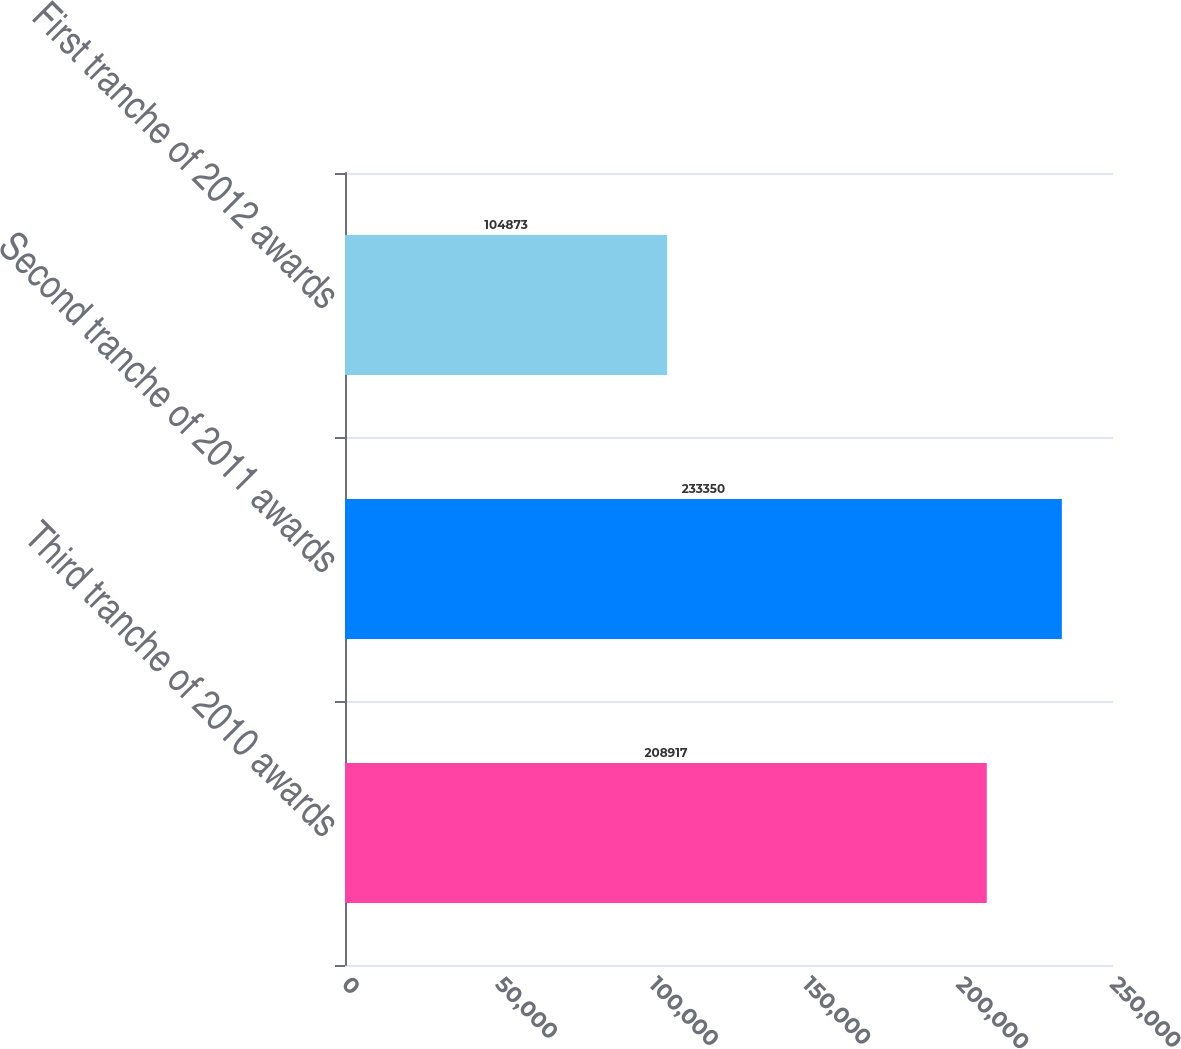<chart> <loc_0><loc_0><loc_500><loc_500><bar_chart><fcel>Third tranche of 2010 awards<fcel>Second tranche of 2011 awards<fcel>First tranche of 2012 awards<nl><fcel>208917<fcel>233350<fcel>104873<nl></chart> 